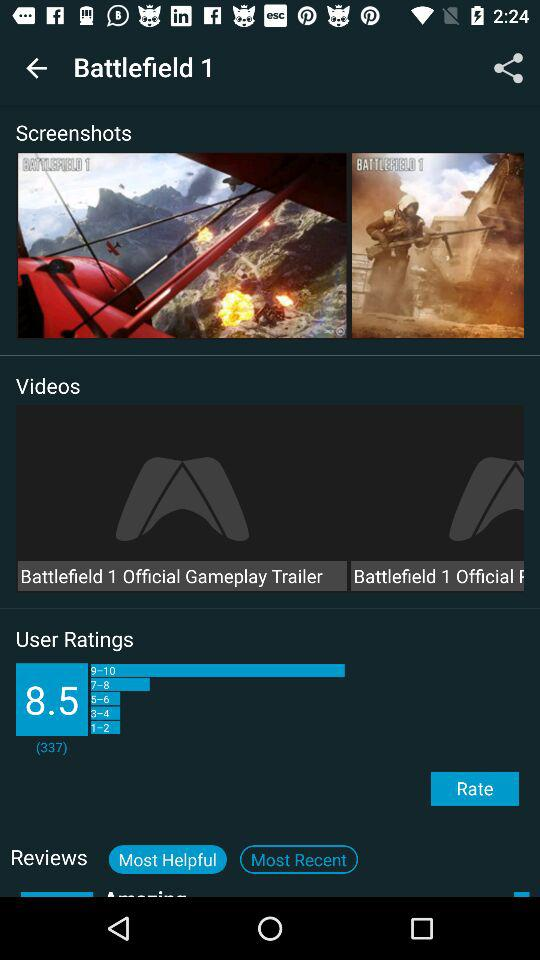Which applications are available for sharing the game?
When the provided information is insufficient, respond with <no answer>. <no answer> 